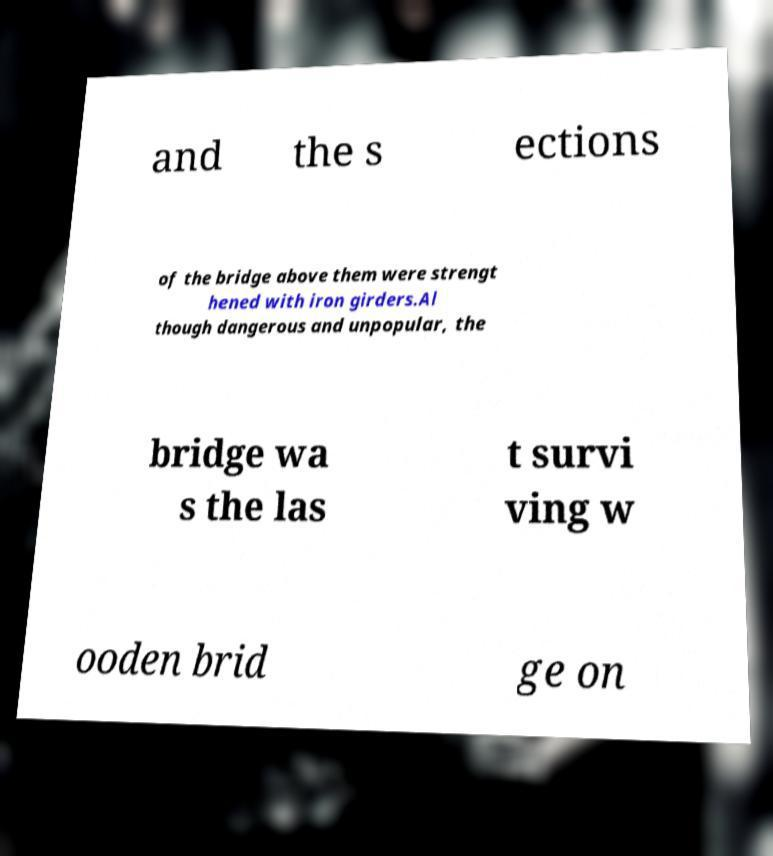Can you read and provide the text displayed in the image?This photo seems to have some interesting text. Can you extract and type it out for me? and the s ections of the bridge above them were strengt hened with iron girders.Al though dangerous and unpopular, the bridge wa s the las t survi ving w ooden brid ge on 